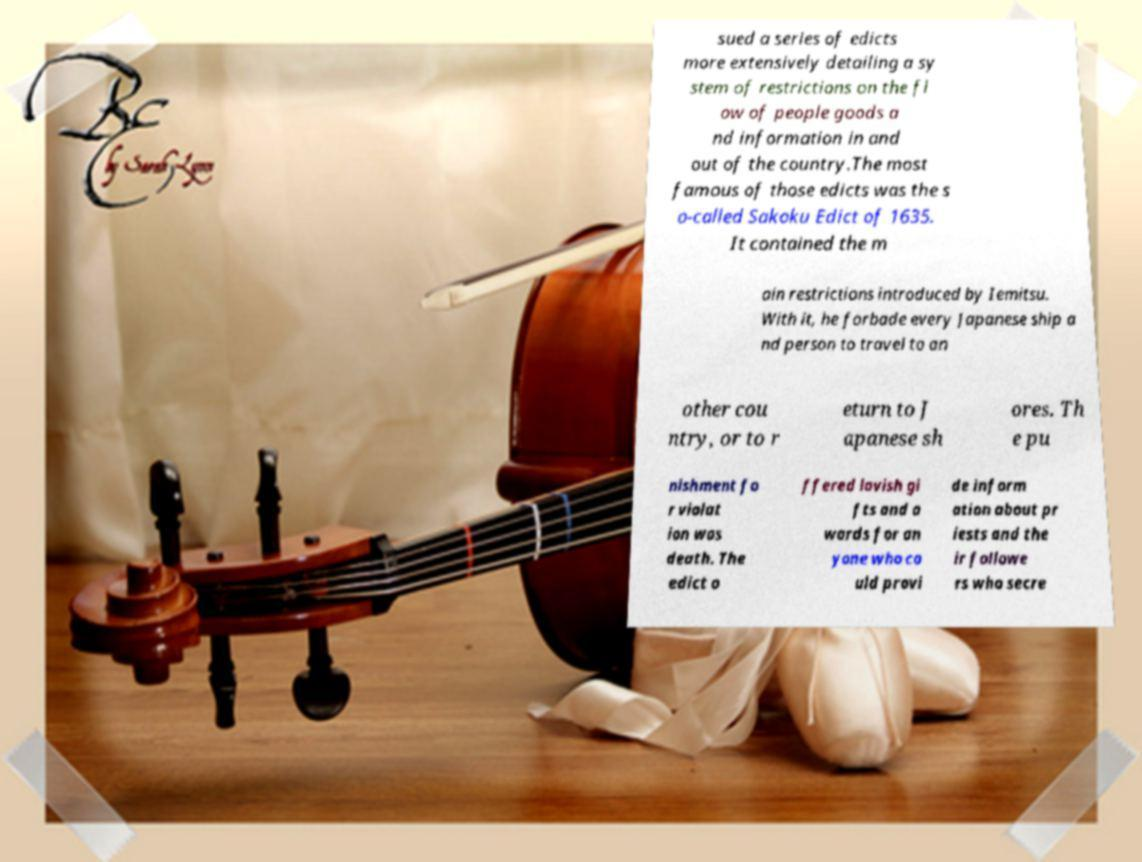Can you read and provide the text displayed in the image?This photo seems to have some interesting text. Can you extract and type it out for me? sued a series of edicts more extensively detailing a sy stem of restrictions on the fl ow of people goods a nd information in and out of the country.The most famous of those edicts was the s o-called Sakoku Edict of 1635. It contained the m ain restrictions introduced by Iemitsu. With it, he forbade every Japanese ship a nd person to travel to an other cou ntry, or to r eturn to J apanese sh ores. Th e pu nishment fo r violat ion was death. The edict o ffered lavish gi fts and a wards for an yone who co uld provi de inform ation about pr iests and the ir followe rs who secre 